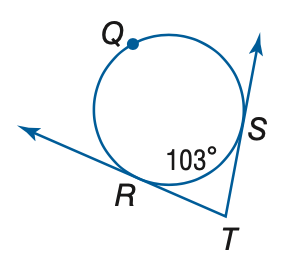Question: Find the measure of \angle T.
Choices:
A. 60
B. 77
C. 103
D. 154
Answer with the letter. Answer: B 